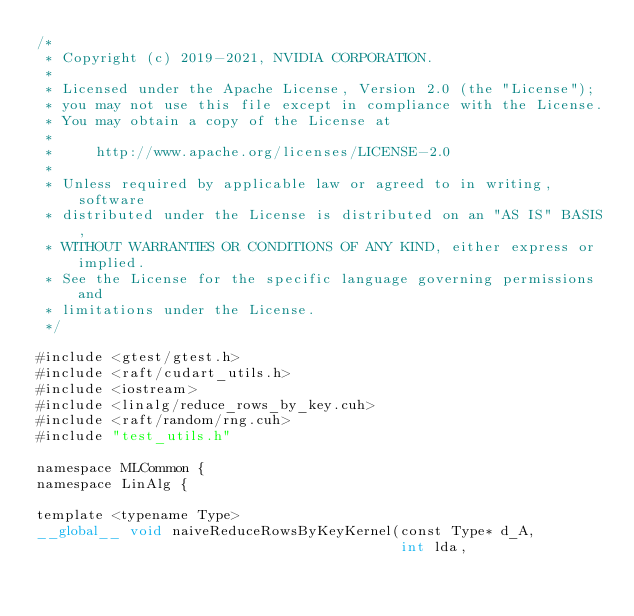<code> <loc_0><loc_0><loc_500><loc_500><_Cuda_>/*
 * Copyright (c) 2019-2021, NVIDIA CORPORATION.
 *
 * Licensed under the Apache License, Version 2.0 (the "License");
 * you may not use this file except in compliance with the License.
 * You may obtain a copy of the License at
 *
 *     http://www.apache.org/licenses/LICENSE-2.0
 *
 * Unless required by applicable law or agreed to in writing, software
 * distributed under the License is distributed on an "AS IS" BASIS,
 * WITHOUT WARRANTIES OR CONDITIONS OF ANY KIND, either express or implied.
 * See the License for the specific language governing permissions and
 * limitations under the License.
 */

#include <gtest/gtest.h>
#include <raft/cudart_utils.h>
#include <iostream>
#include <linalg/reduce_rows_by_key.cuh>
#include <raft/random/rng.cuh>
#include "test_utils.h"

namespace MLCommon {
namespace LinAlg {

template <typename Type>
__global__ void naiveReduceRowsByKeyKernel(const Type* d_A,
                                           int lda,</code> 